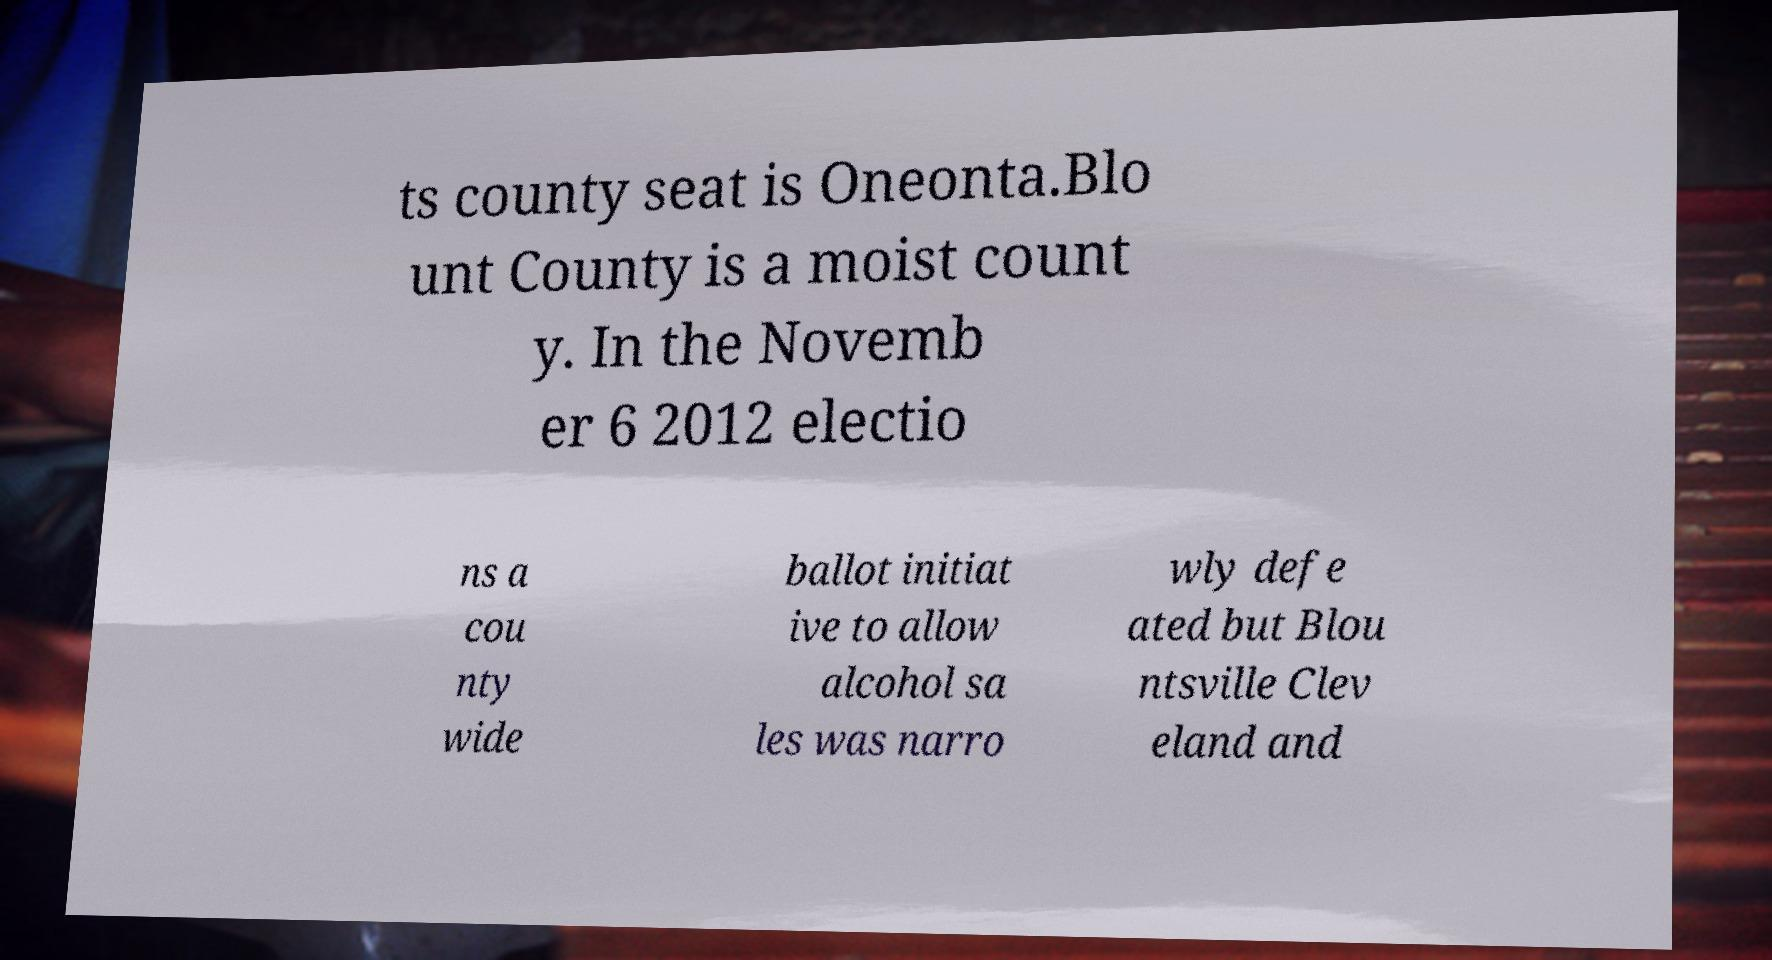Please identify and transcribe the text found in this image. ts county seat is Oneonta.Blo unt County is a moist count y. In the Novemb er 6 2012 electio ns a cou nty wide ballot initiat ive to allow alcohol sa les was narro wly defe ated but Blou ntsville Clev eland and 